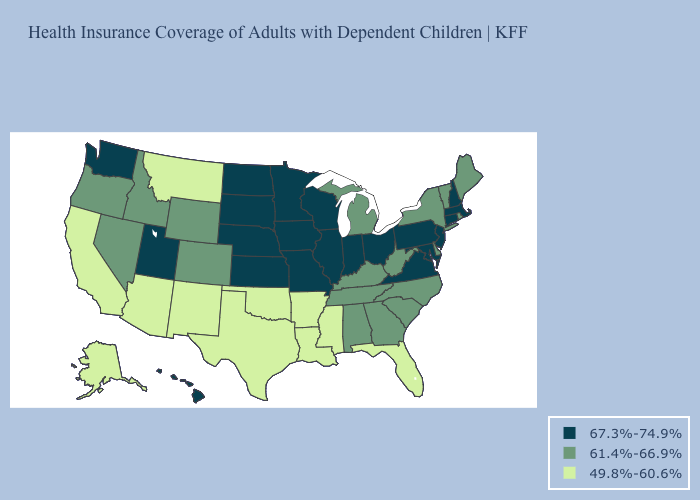Does Rhode Island have the highest value in the Northeast?
Quick response, please. No. Name the states that have a value in the range 61.4%-66.9%?
Concise answer only. Alabama, Colorado, Delaware, Georgia, Idaho, Kentucky, Maine, Michigan, Nevada, New York, North Carolina, Oregon, Rhode Island, South Carolina, Tennessee, Vermont, West Virginia, Wyoming. Does Texas have a lower value than Wisconsin?
Quick response, please. Yes. What is the value of South Dakota?
Short answer required. 67.3%-74.9%. Does Louisiana have the same value as Mississippi?
Be succinct. Yes. Name the states that have a value in the range 49.8%-60.6%?
Give a very brief answer. Alaska, Arizona, Arkansas, California, Florida, Louisiana, Mississippi, Montana, New Mexico, Oklahoma, Texas. What is the value of Kentucky?
Be succinct. 61.4%-66.9%. Name the states that have a value in the range 67.3%-74.9%?
Be succinct. Connecticut, Hawaii, Illinois, Indiana, Iowa, Kansas, Maryland, Massachusetts, Minnesota, Missouri, Nebraska, New Hampshire, New Jersey, North Dakota, Ohio, Pennsylvania, South Dakota, Utah, Virginia, Washington, Wisconsin. What is the value of New York?
Concise answer only. 61.4%-66.9%. What is the lowest value in the West?
Keep it brief. 49.8%-60.6%. Which states have the highest value in the USA?
Keep it brief. Connecticut, Hawaii, Illinois, Indiana, Iowa, Kansas, Maryland, Massachusetts, Minnesota, Missouri, Nebraska, New Hampshire, New Jersey, North Dakota, Ohio, Pennsylvania, South Dakota, Utah, Virginia, Washington, Wisconsin. Is the legend a continuous bar?
Short answer required. No. Name the states that have a value in the range 67.3%-74.9%?
Write a very short answer. Connecticut, Hawaii, Illinois, Indiana, Iowa, Kansas, Maryland, Massachusetts, Minnesota, Missouri, Nebraska, New Hampshire, New Jersey, North Dakota, Ohio, Pennsylvania, South Dakota, Utah, Virginia, Washington, Wisconsin. What is the value of New Hampshire?
Quick response, please. 67.3%-74.9%. What is the value of Tennessee?
Keep it brief. 61.4%-66.9%. 